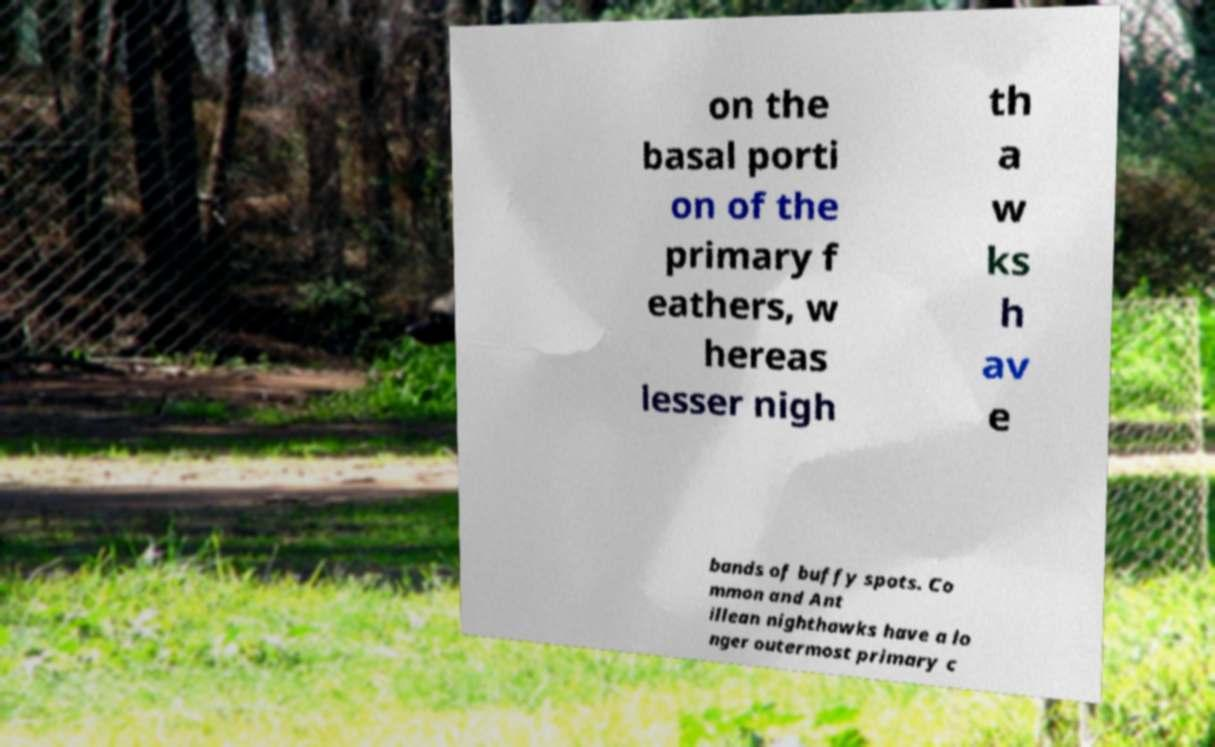Can you accurately transcribe the text from the provided image for me? on the basal porti on of the primary f eathers, w hereas lesser nigh th a w ks h av e bands of buffy spots. Co mmon and Ant illean nighthawks have a lo nger outermost primary c 